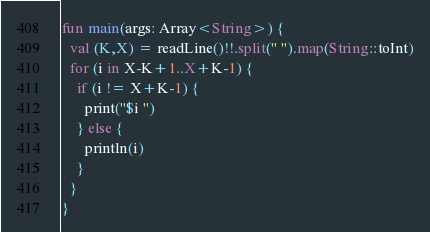Convert code to text. <code><loc_0><loc_0><loc_500><loc_500><_Kotlin_>fun main(args: Array<String>) {
  val (K,X) = readLine()!!.split(" ").map(String::toInt)
  for (i in X-K+1..X+K-1) {
    if (i != X+K-1) {
      print("$i ")
    } else {
      println(i)
    }
  }
}</code> 